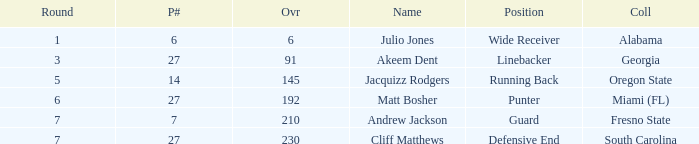Which name had more than 5 rounds and was a defensive end? Cliff Matthews. 